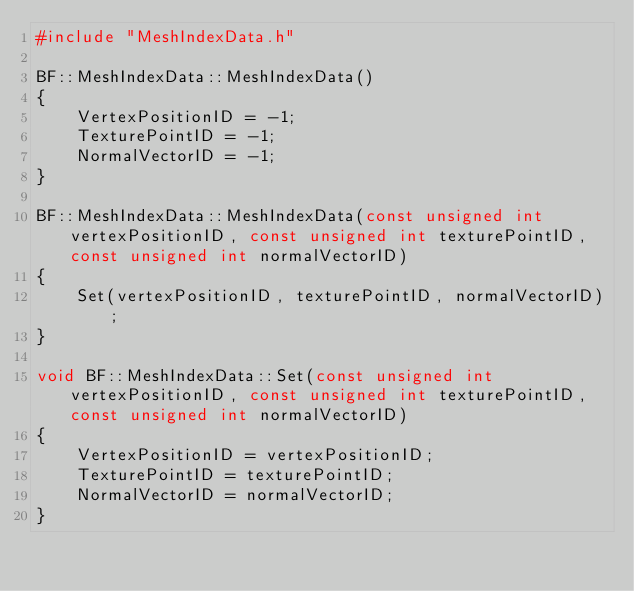Convert code to text. <code><loc_0><loc_0><loc_500><loc_500><_C++_>#include "MeshIndexData.h"

BF::MeshIndexData::MeshIndexData()
{
	VertexPositionID = -1;
	TexturePointID = -1;
	NormalVectorID = -1;
}

BF::MeshIndexData::MeshIndexData(const unsigned int vertexPositionID, const unsigned int texturePointID, const unsigned int normalVectorID)
{
	Set(vertexPositionID, texturePointID, normalVectorID);
}

void BF::MeshIndexData::Set(const unsigned int vertexPositionID, const unsigned int texturePointID, const unsigned int normalVectorID)
{
	VertexPositionID = vertexPositionID;
	TexturePointID = texturePointID;
	NormalVectorID = normalVectorID;
}
</code> 